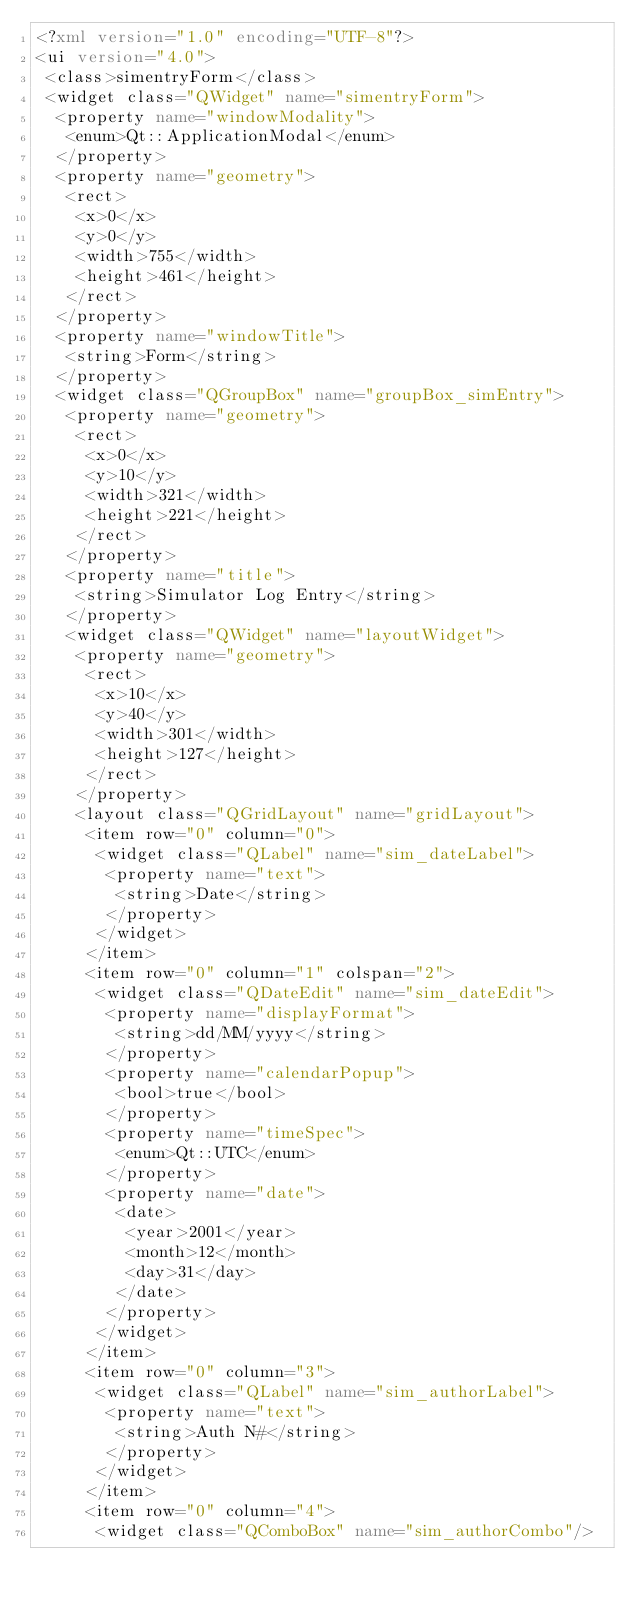Convert code to text. <code><loc_0><loc_0><loc_500><loc_500><_XML_><?xml version="1.0" encoding="UTF-8"?>
<ui version="4.0">
 <class>simentryForm</class>
 <widget class="QWidget" name="simentryForm">
  <property name="windowModality">
   <enum>Qt::ApplicationModal</enum>
  </property>
  <property name="geometry">
   <rect>
    <x>0</x>
    <y>0</y>
    <width>755</width>
    <height>461</height>
   </rect>
  </property>
  <property name="windowTitle">
   <string>Form</string>
  </property>
  <widget class="QGroupBox" name="groupBox_simEntry">
   <property name="geometry">
    <rect>
     <x>0</x>
     <y>10</y>
     <width>321</width>
     <height>221</height>
    </rect>
   </property>
   <property name="title">
    <string>Simulator Log Entry</string>
   </property>
   <widget class="QWidget" name="layoutWidget">
    <property name="geometry">
     <rect>
      <x>10</x>
      <y>40</y>
      <width>301</width>
      <height>127</height>
     </rect>
    </property>
    <layout class="QGridLayout" name="gridLayout">
     <item row="0" column="0">
      <widget class="QLabel" name="sim_dateLabel">
       <property name="text">
        <string>Date</string>
       </property>
      </widget>
     </item>
     <item row="0" column="1" colspan="2">
      <widget class="QDateEdit" name="sim_dateEdit">
       <property name="displayFormat">
        <string>dd/MM/yyyy</string>
       </property>
       <property name="calendarPopup">
        <bool>true</bool>
       </property>
       <property name="timeSpec">
        <enum>Qt::UTC</enum>
       </property>
       <property name="date">
        <date>
         <year>2001</year>
         <month>12</month>
         <day>31</day>
        </date>
       </property>
      </widget>
     </item>
     <item row="0" column="3">
      <widget class="QLabel" name="sim_authorLabel">
       <property name="text">
        <string>Auth N#</string>
       </property>
      </widget>
     </item>
     <item row="0" column="4">
      <widget class="QComboBox" name="sim_authorCombo"/></code> 